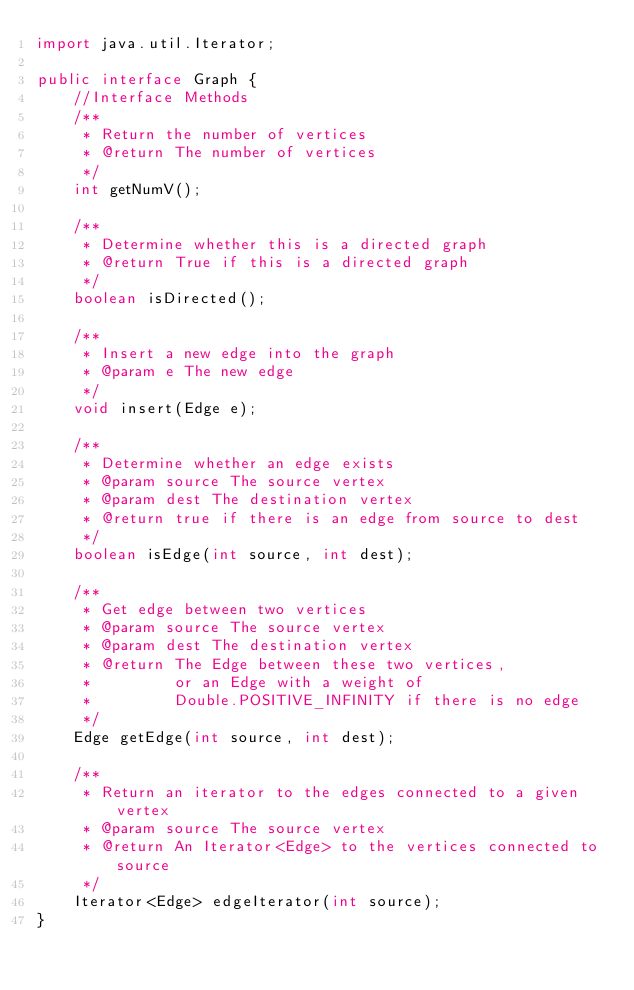Convert code to text. <code><loc_0><loc_0><loc_500><loc_500><_Java_>import java.util.Iterator;

public interface Graph {
    //Interface Methods
    /**
     * Return the number of vertices
     * @return The number of vertices
     */
    int getNumV();

    /**
     * Determine whether this is a directed graph
     * @return True if this is a directed graph
     */
    boolean isDirected();

    /**
     * Insert a new edge into the graph
     * @param e The new edge
     */
    void insert(Edge e);

    /**
     * Determine whether an edge exists
     * @param source The source vertex
     * @param dest The destination vertex
     * @return true if there is an edge from source to dest
     */
    boolean isEdge(int source, int dest);

    /**
     * Get edge between two vertices
     * @param source The source vertex
     * @param dest The destination vertex
     * @return The Edge between these two vertices,
     *         or an Edge with a weight of
     *         Double.POSITIVE_INFINITY if there is no edge
     */
    Edge getEdge(int source, int dest);

    /**
     * Return an iterator to the edges connected to a given vertex
     * @param source The source vertex
     * @return An Iterator<Edge> to the vertices connected to source
     */
    Iterator<Edge> edgeIterator(int source);
}</code> 